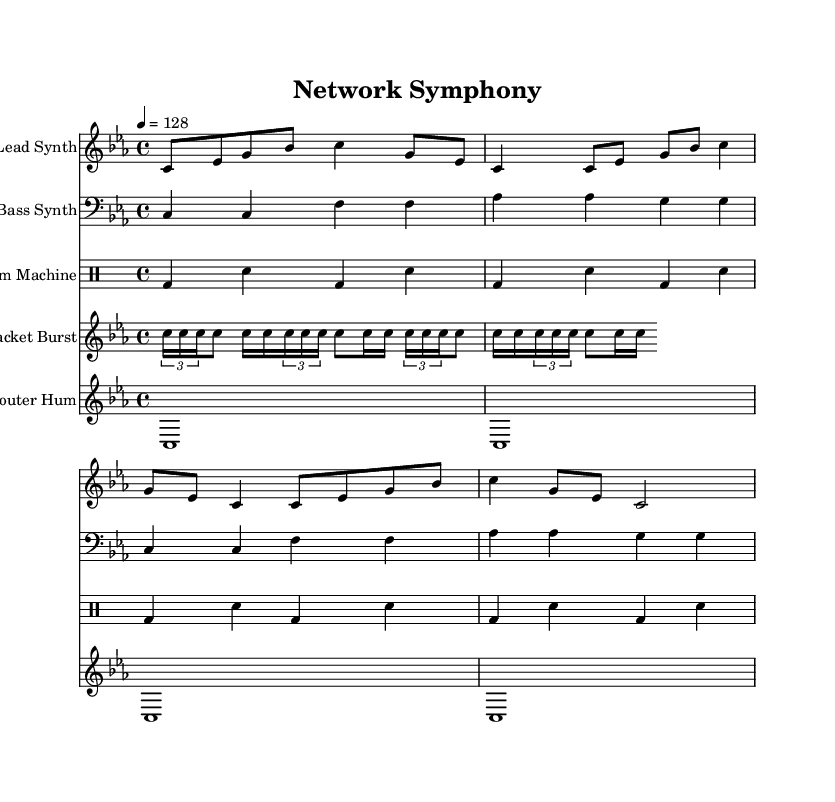What is the key signature of this music? The key signature is C minor, which features three flats (B flat, E flat, and A flat). This is derived from the key indicated at the beginning of the score.
Answer: C minor What is the time signature of this music? The time signature is 4/4, which is evident from the notation written at the beginning of the score. This indicates that there are four beats in each measure and that the quarter note gets one beat.
Answer: 4/4 What is the tempo marking given in the sheet music? The tempo marking indicates a tempo of quarter note equals 128 beats per minute, denoted as "4 = 128" in the score. This informs the player how fast the music should be played.
Answer: 128 How many measures are present in the "Lead Synth" part? The "Lead Synth" part consists of four measures, as each section in the score is demarcated by vertical lines indicating the end of measures, and those containing the lead synth show a total of four distinct groups.
Answer: 4 Which instrument plays the "drum pattern"? The drum pattern is played by the "Drum Machine," which is labeled clearly under the specific staff designated for drums in the score.
Answer: Drum Machine What kind of rhythmic pattern does the "Packet Burst" section feature? The "Packet Burst" section features a tupleted rhythm, specifically 3/2 tuplets in its notation, indicating that three notes are played in the duration normally allocated for two, enhancing the electronic feel of the piece.
Answer: Tupleted What is the texture of the piece in terms of the number of distinct voices or instruments used? The piece uses five distinct voices or instruments, shown by the five separate staves labeled accordingly: Lead Synth, Bass Synth, Drum Machine, Packet Burst, and Router Hum. This demonstrates a layered texture typical in electronic compositions.
Answer: 5 